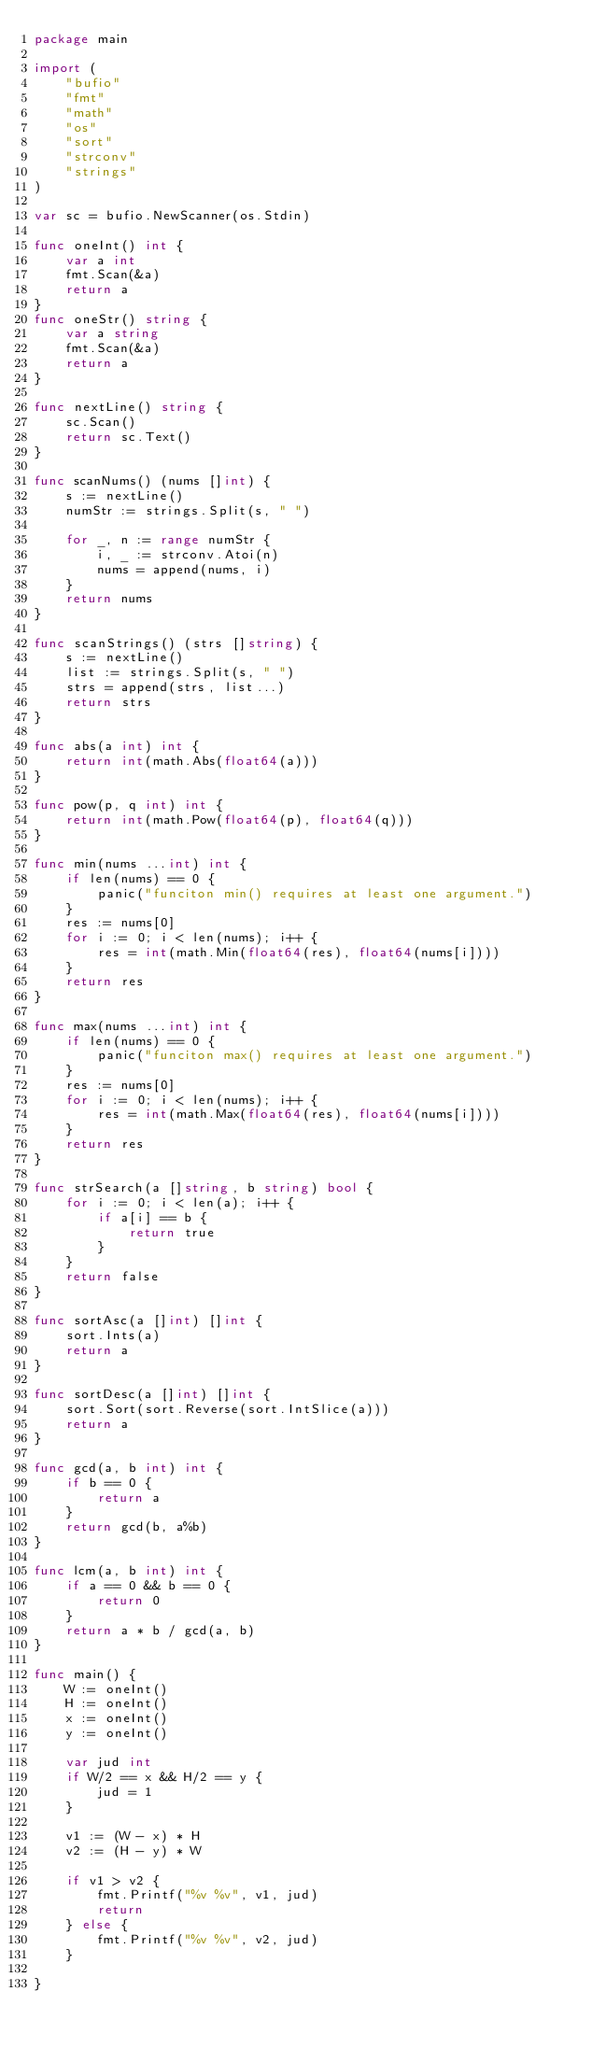Convert code to text. <code><loc_0><loc_0><loc_500><loc_500><_Go_>package main

import (
	"bufio"
	"fmt"
	"math"
	"os"
	"sort"
	"strconv"
	"strings"
)

var sc = bufio.NewScanner(os.Stdin)

func oneInt() int {
	var a int
	fmt.Scan(&a)
	return a
}
func oneStr() string {
	var a string
	fmt.Scan(&a)
	return a
}

func nextLine() string {
	sc.Scan()
	return sc.Text()
}

func scanNums() (nums []int) {
	s := nextLine()
	numStr := strings.Split(s, " ")

	for _, n := range numStr {
		i, _ := strconv.Atoi(n)
		nums = append(nums, i)
	}
	return nums
}

func scanStrings() (strs []string) {
	s := nextLine()
	list := strings.Split(s, " ")
	strs = append(strs, list...)
	return strs
}

func abs(a int) int {
	return int(math.Abs(float64(a)))
}

func pow(p, q int) int {
	return int(math.Pow(float64(p), float64(q)))
}

func min(nums ...int) int {
	if len(nums) == 0 {
		panic("funciton min() requires at least one argument.")
	}
	res := nums[0]
	for i := 0; i < len(nums); i++ {
		res = int(math.Min(float64(res), float64(nums[i])))
	}
	return res
}

func max(nums ...int) int {
	if len(nums) == 0 {
		panic("funciton max() requires at least one argument.")
	}
	res := nums[0]
	for i := 0; i < len(nums); i++ {
		res = int(math.Max(float64(res), float64(nums[i])))
	}
	return res
}

func strSearch(a []string, b string) bool {
	for i := 0; i < len(a); i++ {
		if a[i] == b {
			return true
		}
	}
	return false
}

func sortAsc(a []int) []int {
	sort.Ints(a)
	return a
}

func sortDesc(a []int) []int {
	sort.Sort(sort.Reverse(sort.IntSlice(a)))
	return a
}

func gcd(a, b int) int {
	if b == 0 {
		return a
	}
	return gcd(b, a%b)
}

func lcm(a, b int) int {
	if a == 0 && b == 0 {
		return 0
	}
	return a * b / gcd(a, b)
}

func main() {
	W := oneInt()
	H := oneInt()
	x := oneInt()
	y := oneInt()

	var jud int
	if W/2 == x && H/2 == y {
		jud = 1
	}

	v1 := (W - x) * H
	v2 := (H - y) * W

	if v1 > v2 {
		fmt.Printf("%v %v", v1, jud)
		return
	} else {
		fmt.Printf("%v %v", v2, jud)
	}

}
</code> 